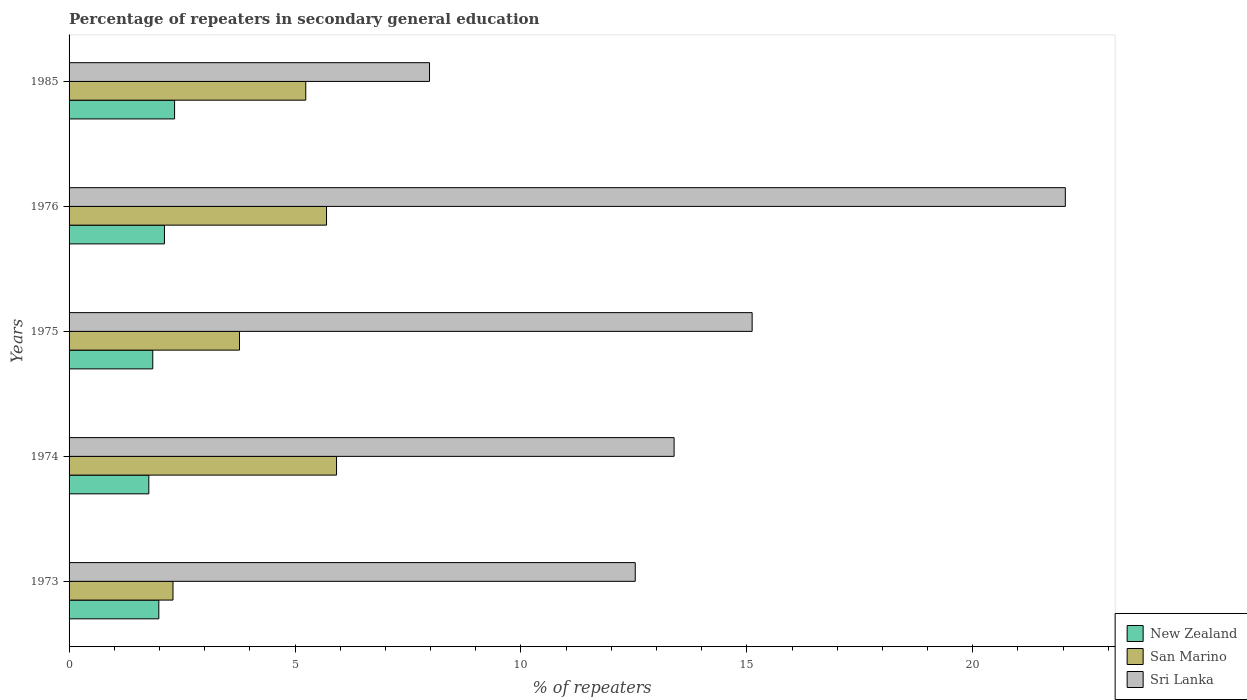How many groups of bars are there?
Give a very brief answer. 5. Are the number of bars per tick equal to the number of legend labels?
Give a very brief answer. Yes. How many bars are there on the 2nd tick from the top?
Offer a terse response. 3. In how many cases, is the number of bars for a given year not equal to the number of legend labels?
Offer a terse response. 0. What is the percentage of repeaters in secondary general education in Sri Lanka in 1985?
Keep it short and to the point. 7.98. Across all years, what is the maximum percentage of repeaters in secondary general education in San Marino?
Keep it short and to the point. 5.92. Across all years, what is the minimum percentage of repeaters in secondary general education in Sri Lanka?
Ensure brevity in your answer.  7.98. In which year was the percentage of repeaters in secondary general education in San Marino maximum?
Ensure brevity in your answer.  1974. What is the total percentage of repeaters in secondary general education in New Zealand in the graph?
Give a very brief answer. 10.05. What is the difference between the percentage of repeaters in secondary general education in Sri Lanka in 1973 and that in 1985?
Your answer should be very brief. 4.55. What is the difference between the percentage of repeaters in secondary general education in New Zealand in 1985 and the percentage of repeaters in secondary general education in Sri Lanka in 1976?
Your answer should be compact. -19.71. What is the average percentage of repeaters in secondary general education in San Marino per year?
Offer a very short reply. 4.59. In the year 1974, what is the difference between the percentage of repeaters in secondary general education in Sri Lanka and percentage of repeaters in secondary general education in New Zealand?
Provide a short and direct response. 11.62. What is the ratio of the percentage of repeaters in secondary general education in Sri Lanka in 1973 to that in 1975?
Give a very brief answer. 0.83. Is the difference between the percentage of repeaters in secondary general education in Sri Lanka in 1975 and 1976 greater than the difference between the percentage of repeaters in secondary general education in New Zealand in 1975 and 1976?
Offer a terse response. No. What is the difference between the highest and the second highest percentage of repeaters in secondary general education in San Marino?
Offer a very short reply. 0.22. What is the difference between the highest and the lowest percentage of repeaters in secondary general education in Sri Lanka?
Your answer should be compact. 14.07. In how many years, is the percentage of repeaters in secondary general education in Sri Lanka greater than the average percentage of repeaters in secondary general education in Sri Lanka taken over all years?
Keep it short and to the point. 2. What does the 3rd bar from the top in 1974 represents?
Make the answer very short. New Zealand. What does the 3rd bar from the bottom in 1974 represents?
Ensure brevity in your answer.  Sri Lanka. Are all the bars in the graph horizontal?
Your answer should be very brief. Yes. What is the difference between two consecutive major ticks on the X-axis?
Keep it short and to the point. 5. Are the values on the major ticks of X-axis written in scientific E-notation?
Your answer should be very brief. No. Does the graph contain any zero values?
Ensure brevity in your answer.  No. Where does the legend appear in the graph?
Your answer should be very brief. Bottom right. How many legend labels are there?
Offer a very short reply. 3. How are the legend labels stacked?
Offer a very short reply. Vertical. What is the title of the graph?
Your response must be concise. Percentage of repeaters in secondary general education. What is the label or title of the X-axis?
Your response must be concise. % of repeaters. What is the label or title of the Y-axis?
Ensure brevity in your answer.  Years. What is the % of repeaters of New Zealand in 1973?
Make the answer very short. 1.99. What is the % of repeaters of San Marino in 1973?
Keep it short and to the point. 2.3. What is the % of repeaters in Sri Lanka in 1973?
Keep it short and to the point. 12.53. What is the % of repeaters in New Zealand in 1974?
Your answer should be very brief. 1.77. What is the % of repeaters in San Marino in 1974?
Offer a very short reply. 5.92. What is the % of repeaters in Sri Lanka in 1974?
Your response must be concise. 13.39. What is the % of repeaters in New Zealand in 1975?
Offer a very short reply. 1.85. What is the % of repeaters in San Marino in 1975?
Give a very brief answer. 3.77. What is the % of repeaters in Sri Lanka in 1975?
Keep it short and to the point. 15.12. What is the % of repeaters in New Zealand in 1976?
Your answer should be very brief. 2.11. What is the % of repeaters of San Marino in 1976?
Offer a terse response. 5.7. What is the % of repeaters in Sri Lanka in 1976?
Offer a terse response. 22.05. What is the % of repeaters in New Zealand in 1985?
Offer a very short reply. 2.33. What is the % of repeaters of San Marino in 1985?
Your answer should be very brief. 5.24. What is the % of repeaters in Sri Lanka in 1985?
Give a very brief answer. 7.98. Across all years, what is the maximum % of repeaters of New Zealand?
Keep it short and to the point. 2.33. Across all years, what is the maximum % of repeaters of San Marino?
Make the answer very short. 5.92. Across all years, what is the maximum % of repeaters of Sri Lanka?
Ensure brevity in your answer.  22.05. Across all years, what is the minimum % of repeaters of New Zealand?
Make the answer very short. 1.77. Across all years, what is the minimum % of repeaters of San Marino?
Your answer should be very brief. 2.3. Across all years, what is the minimum % of repeaters of Sri Lanka?
Your answer should be compact. 7.98. What is the total % of repeaters of New Zealand in the graph?
Provide a succinct answer. 10.05. What is the total % of repeaters in San Marino in the graph?
Offer a very short reply. 22.93. What is the total % of repeaters of Sri Lanka in the graph?
Provide a short and direct response. 71.06. What is the difference between the % of repeaters in New Zealand in 1973 and that in 1974?
Offer a terse response. 0.22. What is the difference between the % of repeaters in San Marino in 1973 and that in 1974?
Give a very brief answer. -3.62. What is the difference between the % of repeaters in Sri Lanka in 1973 and that in 1974?
Your response must be concise. -0.86. What is the difference between the % of repeaters of New Zealand in 1973 and that in 1975?
Ensure brevity in your answer.  0.13. What is the difference between the % of repeaters of San Marino in 1973 and that in 1975?
Provide a succinct answer. -1.47. What is the difference between the % of repeaters in Sri Lanka in 1973 and that in 1975?
Keep it short and to the point. -2.59. What is the difference between the % of repeaters in New Zealand in 1973 and that in 1976?
Offer a terse response. -0.12. What is the difference between the % of repeaters in San Marino in 1973 and that in 1976?
Keep it short and to the point. -3.4. What is the difference between the % of repeaters in Sri Lanka in 1973 and that in 1976?
Keep it short and to the point. -9.52. What is the difference between the % of repeaters in New Zealand in 1973 and that in 1985?
Your answer should be compact. -0.35. What is the difference between the % of repeaters in San Marino in 1973 and that in 1985?
Your answer should be very brief. -2.94. What is the difference between the % of repeaters of Sri Lanka in 1973 and that in 1985?
Provide a short and direct response. 4.55. What is the difference between the % of repeaters of New Zealand in 1974 and that in 1975?
Provide a short and direct response. -0.09. What is the difference between the % of repeaters of San Marino in 1974 and that in 1975?
Give a very brief answer. 2.15. What is the difference between the % of repeaters of Sri Lanka in 1974 and that in 1975?
Offer a terse response. -1.73. What is the difference between the % of repeaters of New Zealand in 1974 and that in 1976?
Keep it short and to the point. -0.35. What is the difference between the % of repeaters of San Marino in 1974 and that in 1976?
Ensure brevity in your answer.  0.22. What is the difference between the % of repeaters in Sri Lanka in 1974 and that in 1976?
Provide a short and direct response. -8.66. What is the difference between the % of repeaters of New Zealand in 1974 and that in 1985?
Ensure brevity in your answer.  -0.57. What is the difference between the % of repeaters in San Marino in 1974 and that in 1985?
Provide a succinct answer. 0.68. What is the difference between the % of repeaters of Sri Lanka in 1974 and that in 1985?
Offer a terse response. 5.41. What is the difference between the % of repeaters of New Zealand in 1975 and that in 1976?
Offer a very short reply. -0.26. What is the difference between the % of repeaters of San Marino in 1975 and that in 1976?
Provide a succinct answer. -1.93. What is the difference between the % of repeaters in Sri Lanka in 1975 and that in 1976?
Ensure brevity in your answer.  -6.93. What is the difference between the % of repeaters in New Zealand in 1975 and that in 1985?
Keep it short and to the point. -0.48. What is the difference between the % of repeaters in San Marino in 1975 and that in 1985?
Make the answer very short. -1.47. What is the difference between the % of repeaters of Sri Lanka in 1975 and that in 1985?
Make the answer very short. 7.14. What is the difference between the % of repeaters in New Zealand in 1976 and that in 1985?
Keep it short and to the point. -0.22. What is the difference between the % of repeaters in San Marino in 1976 and that in 1985?
Give a very brief answer. 0.46. What is the difference between the % of repeaters in Sri Lanka in 1976 and that in 1985?
Offer a very short reply. 14.07. What is the difference between the % of repeaters of New Zealand in 1973 and the % of repeaters of San Marino in 1974?
Ensure brevity in your answer.  -3.93. What is the difference between the % of repeaters in New Zealand in 1973 and the % of repeaters in Sri Lanka in 1974?
Your answer should be compact. -11.4. What is the difference between the % of repeaters of San Marino in 1973 and the % of repeaters of Sri Lanka in 1974?
Make the answer very short. -11.09. What is the difference between the % of repeaters in New Zealand in 1973 and the % of repeaters in San Marino in 1975?
Your answer should be very brief. -1.79. What is the difference between the % of repeaters in New Zealand in 1973 and the % of repeaters in Sri Lanka in 1975?
Give a very brief answer. -13.13. What is the difference between the % of repeaters of San Marino in 1973 and the % of repeaters of Sri Lanka in 1975?
Keep it short and to the point. -12.82. What is the difference between the % of repeaters of New Zealand in 1973 and the % of repeaters of San Marino in 1976?
Make the answer very short. -3.71. What is the difference between the % of repeaters of New Zealand in 1973 and the % of repeaters of Sri Lanka in 1976?
Offer a very short reply. -20.06. What is the difference between the % of repeaters of San Marino in 1973 and the % of repeaters of Sri Lanka in 1976?
Your response must be concise. -19.75. What is the difference between the % of repeaters in New Zealand in 1973 and the % of repeaters in San Marino in 1985?
Keep it short and to the point. -3.25. What is the difference between the % of repeaters of New Zealand in 1973 and the % of repeaters of Sri Lanka in 1985?
Your response must be concise. -5.99. What is the difference between the % of repeaters of San Marino in 1973 and the % of repeaters of Sri Lanka in 1985?
Provide a short and direct response. -5.68. What is the difference between the % of repeaters of New Zealand in 1974 and the % of repeaters of San Marino in 1975?
Make the answer very short. -2.01. What is the difference between the % of repeaters in New Zealand in 1974 and the % of repeaters in Sri Lanka in 1975?
Give a very brief answer. -13.35. What is the difference between the % of repeaters in San Marino in 1974 and the % of repeaters in Sri Lanka in 1975?
Keep it short and to the point. -9.2. What is the difference between the % of repeaters of New Zealand in 1974 and the % of repeaters of San Marino in 1976?
Give a very brief answer. -3.93. What is the difference between the % of repeaters of New Zealand in 1974 and the % of repeaters of Sri Lanka in 1976?
Give a very brief answer. -20.28. What is the difference between the % of repeaters in San Marino in 1974 and the % of repeaters in Sri Lanka in 1976?
Make the answer very short. -16.13. What is the difference between the % of repeaters in New Zealand in 1974 and the % of repeaters in San Marino in 1985?
Offer a very short reply. -3.47. What is the difference between the % of repeaters of New Zealand in 1974 and the % of repeaters of Sri Lanka in 1985?
Provide a succinct answer. -6.21. What is the difference between the % of repeaters in San Marino in 1974 and the % of repeaters in Sri Lanka in 1985?
Provide a succinct answer. -2.06. What is the difference between the % of repeaters of New Zealand in 1975 and the % of repeaters of San Marino in 1976?
Your answer should be compact. -3.85. What is the difference between the % of repeaters of New Zealand in 1975 and the % of repeaters of Sri Lanka in 1976?
Offer a very short reply. -20.2. What is the difference between the % of repeaters of San Marino in 1975 and the % of repeaters of Sri Lanka in 1976?
Make the answer very short. -18.28. What is the difference between the % of repeaters in New Zealand in 1975 and the % of repeaters in San Marino in 1985?
Give a very brief answer. -3.39. What is the difference between the % of repeaters of New Zealand in 1975 and the % of repeaters of Sri Lanka in 1985?
Provide a short and direct response. -6.12. What is the difference between the % of repeaters in San Marino in 1975 and the % of repeaters in Sri Lanka in 1985?
Provide a short and direct response. -4.2. What is the difference between the % of repeaters in New Zealand in 1976 and the % of repeaters in San Marino in 1985?
Make the answer very short. -3.13. What is the difference between the % of repeaters of New Zealand in 1976 and the % of repeaters of Sri Lanka in 1985?
Offer a terse response. -5.87. What is the difference between the % of repeaters of San Marino in 1976 and the % of repeaters of Sri Lanka in 1985?
Provide a succinct answer. -2.28. What is the average % of repeaters in New Zealand per year?
Give a very brief answer. 2.01. What is the average % of repeaters of San Marino per year?
Ensure brevity in your answer.  4.59. What is the average % of repeaters in Sri Lanka per year?
Provide a short and direct response. 14.21. In the year 1973, what is the difference between the % of repeaters in New Zealand and % of repeaters in San Marino?
Give a very brief answer. -0.31. In the year 1973, what is the difference between the % of repeaters in New Zealand and % of repeaters in Sri Lanka?
Make the answer very short. -10.54. In the year 1973, what is the difference between the % of repeaters in San Marino and % of repeaters in Sri Lanka?
Provide a succinct answer. -10.23. In the year 1974, what is the difference between the % of repeaters in New Zealand and % of repeaters in San Marino?
Your answer should be compact. -4.15. In the year 1974, what is the difference between the % of repeaters in New Zealand and % of repeaters in Sri Lanka?
Ensure brevity in your answer.  -11.62. In the year 1974, what is the difference between the % of repeaters of San Marino and % of repeaters of Sri Lanka?
Keep it short and to the point. -7.47. In the year 1975, what is the difference between the % of repeaters of New Zealand and % of repeaters of San Marino?
Provide a short and direct response. -1.92. In the year 1975, what is the difference between the % of repeaters in New Zealand and % of repeaters in Sri Lanka?
Ensure brevity in your answer.  -13.26. In the year 1975, what is the difference between the % of repeaters of San Marino and % of repeaters of Sri Lanka?
Offer a very short reply. -11.34. In the year 1976, what is the difference between the % of repeaters of New Zealand and % of repeaters of San Marino?
Offer a terse response. -3.59. In the year 1976, what is the difference between the % of repeaters in New Zealand and % of repeaters in Sri Lanka?
Provide a short and direct response. -19.94. In the year 1976, what is the difference between the % of repeaters in San Marino and % of repeaters in Sri Lanka?
Offer a terse response. -16.35. In the year 1985, what is the difference between the % of repeaters of New Zealand and % of repeaters of San Marino?
Make the answer very short. -2.9. In the year 1985, what is the difference between the % of repeaters of New Zealand and % of repeaters of Sri Lanka?
Provide a succinct answer. -5.64. In the year 1985, what is the difference between the % of repeaters in San Marino and % of repeaters in Sri Lanka?
Your answer should be compact. -2.74. What is the ratio of the % of repeaters in New Zealand in 1973 to that in 1974?
Your answer should be compact. 1.13. What is the ratio of the % of repeaters of San Marino in 1973 to that in 1974?
Offer a terse response. 0.39. What is the ratio of the % of repeaters in Sri Lanka in 1973 to that in 1974?
Offer a very short reply. 0.94. What is the ratio of the % of repeaters in New Zealand in 1973 to that in 1975?
Offer a very short reply. 1.07. What is the ratio of the % of repeaters in San Marino in 1973 to that in 1975?
Your answer should be very brief. 0.61. What is the ratio of the % of repeaters in Sri Lanka in 1973 to that in 1975?
Your response must be concise. 0.83. What is the ratio of the % of repeaters of New Zealand in 1973 to that in 1976?
Ensure brevity in your answer.  0.94. What is the ratio of the % of repeaters of San Marino in 1973 to that in 1976?
Offer a terse response. 0.4. What is the ratio of the % of repeaters in Sri Lanka in 1973 to that in 1976?
Give a very brief answer. 0.57. What is the ratio of the % of repeaters of New Zealand in 1973 to that in 1985?
Your answer should be very brief. 0.85. What is the ratio of the % of repeaters of San Marino in 1973 to that in 1985?
Offer a terse response. 0.44. What is the ratio of the % of repeaters in Sri Lanka in 1973 to that in 1985?
Provide a short and direct response. 1.57. What is the ratio of the % of repeaters of New Zealand in 1974 to that in 1975?
Give a very brief answer. 0.95. What is the ratio of the % of repeaters of San Marino in 1974 to that in 1975?
Your response must be concise. 1.57. What is the ratio of the % of repeaters of Sri Lanka in 1974 to that in 1975?
Your response must be concise. 0.89. What is the ratio of the % of repeaters in New Zealand in 1974 to that in 1976?
Your response must be concise. 0.84. What is the ratio of the % of repeaters of San Marino in 1974 to that in 1976?
Keep it short and to the point. 1.04. What is the ratio of the % of repeaters in Sri Lanka in 1974 to that in 1976?
Your answer should be compact. 0.61. What is the ratio of the % of repeaters in New Zealand in 1974 to that in 1985?
Your response must be concise. 0.76. What is the ratio of the % of repeaters of San Marino in 1974 to that in 1985?
Provide a short and direct response. 1.13. What is the ratio of the % of repeaters in Sri Lanka in 1974 to that in 1985?
Give a very brief answer. 1.68. What is the ratio of the % of repeaters in New Zealand in 1975 to that in 1976?
Offer a very short reply. 0.88. What is the ratio of the % of repeaters of San Marino in 1975 to that in 1976?
Provide a short and direct response. 0.66. What is the ratio of the % of repeaters of Sri Lanka in 1975 to that in 1976?
Keep it short and to the point. 0.69. What is the ratio of the % of repeaters in New Zealand in 1975 to that in 1985?
Make the answer very short. 0.79. What is the ratio of the % of repeaters in San Marino in 1975 to that in 1985?
Offer a very short reply. 0.72. What is the ratio of the % of repeaters in Sri Lanka in 1975 to that in 1985?
Your answer should be very brief. 1.9. What is the ratio of the % of repeaters of New Zealand in 1976 to that in 1985?
Offer a terse response. 0.9. What is the ratio of the % of repeaters in San Marino in 1976 to that in 1985?
Provide a succinct answer. 1.09. What is the ratio of the % of repeaters of Sri Lanka in 1976 to that in 1985?
Ensure brevity in your answer.  2.76. What is the difference between the highest and the second highest % of repeaters in New Zealand?
Keep it short and to the point. 0.22. What is the difference between the highest and the second highest % of repeaters in San Marino?
Offer a terse response. 0.22. What is the difference between the highest and the second highest % of repeaters in Sri Lanka?
Ensure brevity in your answer.  6.93. What is the difference between the highest and the lowest % of repeaters in New Zealand?
Offer a very short reply. 0.57. What is the difference between the highest and the lowest % of repeaters in San Marino?
Provide a short and direct response. 3.62. What is the difference between the highest and the lowest % of repeaters of Sri Lanka?
Keep it short and to the point. 14.07. 